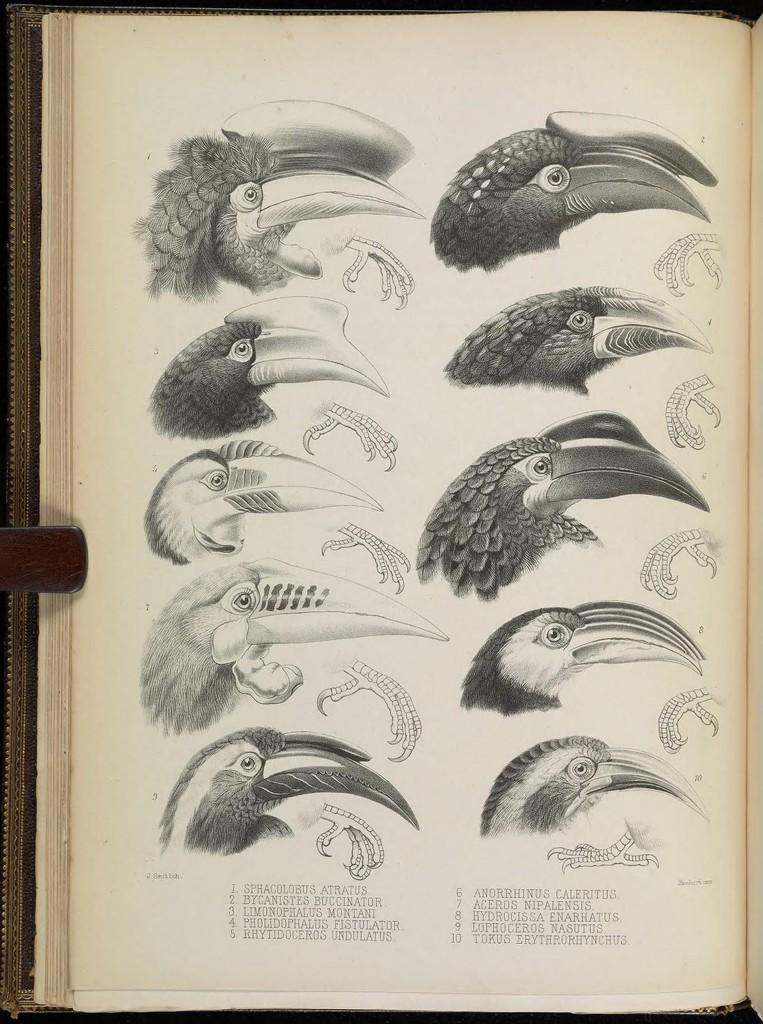What is the main object in the image? There is a book in the image. What can be seen on one of the pages of the book? The book has a page with different kinds of bird faces. Are there any labels or descriptions on the page with bird faces? Yes, the bird names are present at the bottom of the page. What type of toy is being used in the competition in the image? There is no competition or toy present in the image; it features a book with bird faces and names. 